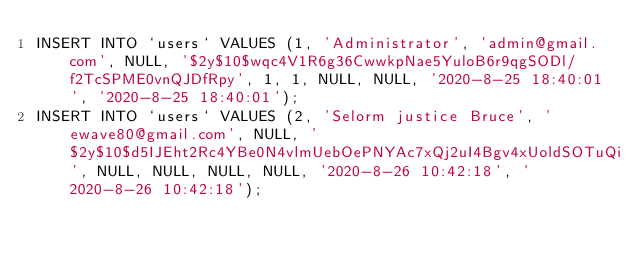<code> <loc_0><loc_0><loc_500><loc_500><_SQL_>INSERT INTO `users` VALUES (1, 'Administrator', 'admin@gmail.com', NULL, '$2y$10$wqc4V1R6g36CwwkpNae5YuloB6r9qgSODl/f2TcSPME0vnQJDfRpy', 1, 1, NULL, NULL, '2020-8-25 18:40:01', '2020-8-25 18:40:01');
INSERT INTO `users` VALUES (2, 'Selorm justice Bruce', 'ewave80@gmail.com', NULL, '$2y$10$d5IJEht2Rc4YBe0N4vlmUebOePNYAc7xQj2uI4Bgv4xUoldSOTuQi', NULL, NULL, NULL, NULL, '2020-8-26 10:42:18', '2020-8-26 10:42:18');
</code> 